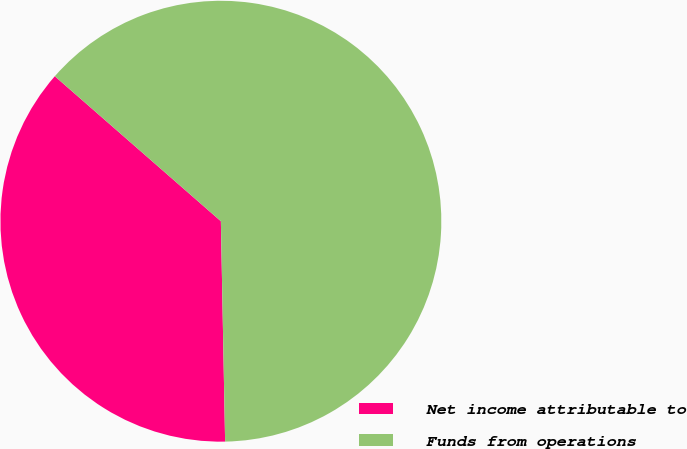<chart> <loc_0><loc_0><loc_500><loc_500><pie_chart><fcel>Net income attributable to<fcel>Funds from operations<nl><fcel>36.73%<fcel>63.27%<nl></chart> 